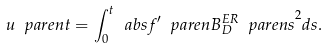Convert formula to latex. <formula><loc_0><loc_0><loc_500><loc_500>u \ p a r e n { t } = \int _ { 0 } ^ { t } \ a b s { f ^ { \prime } \ p a r e n { B ^ { E R } _ { D } \ p a r e n { s } } } ^ { 2 } d s .</formula> 